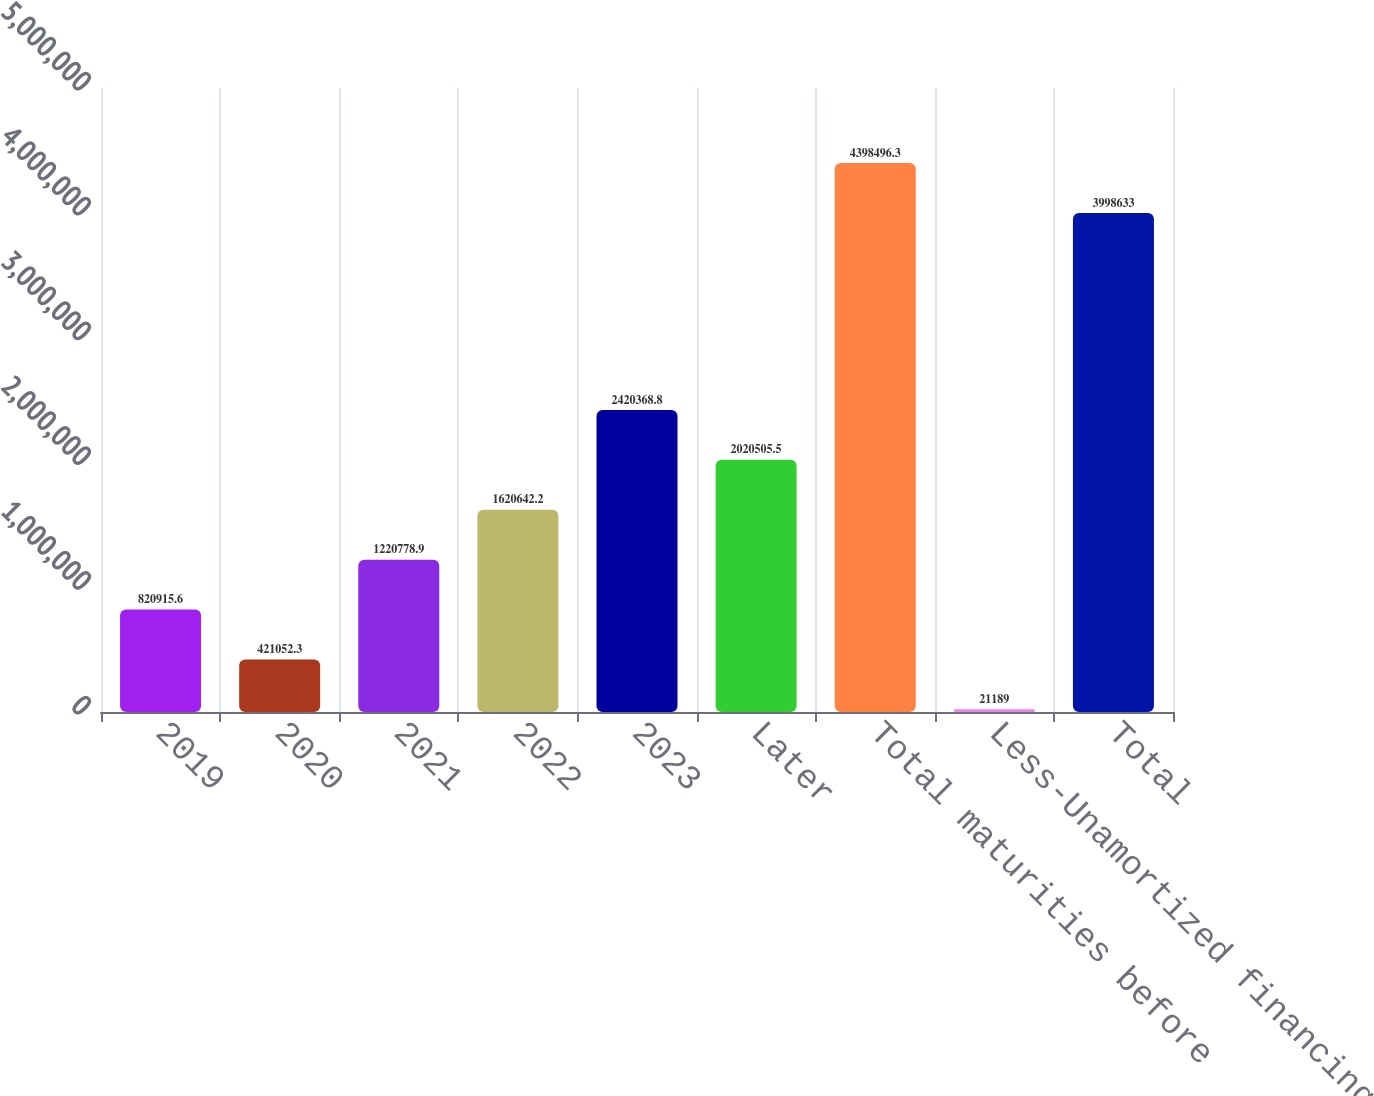Convert chart to OTSL. <chart><loc_0><loc_0><loc_500><loc_500><bar_chart><fcel>2019<fcel>2020<fcel>2021<fcel>2022<fcel>2023<fcel>Later<fcel>Total maturities before<fcel>Less-Unamortized financing<fcel>Total<nl><fcel>820916<fcel>421052<fcel>1.22078e+06<fcel>1.62064e+06<fcel>2.42037e+06<fcel>2.02051e+06<fcel>4.3985e+06<fcel>21189<fcel>3.99863e+06<nl></chart> 